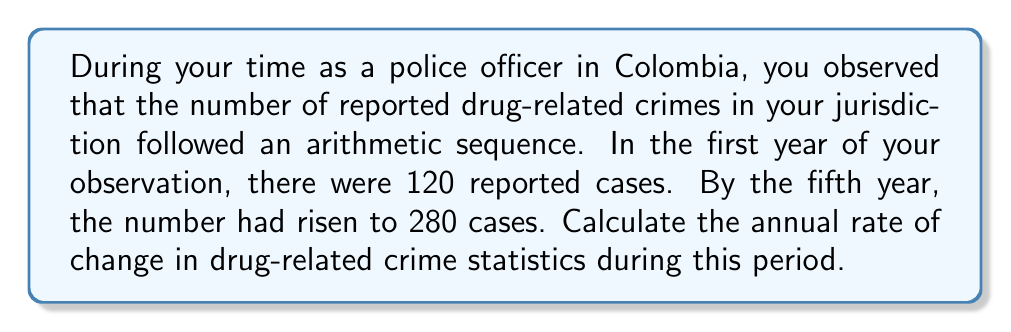Help me with this question. Let's approach this step-by-step:

1) We're dealing with an arithmetic sequence, where the difference between each term is constant. Let's call this common difference $d$.

2) We know two terms in this sequence:
   $a_1 = 120$ (first year)
   $a_5 = 280$ (fifth year)

3) In an arithmetic sequence, the nth term is given by:
   $a_n = a_1 + (n-1)d$

4) We can use this to set up an equation:
   $a_5 = a_1 + (5-1)d$
   $280 = 120 + 4d$

5) Solve for $d$:
   $280 - 120 = 4d$
   $160 = 4d$
   $d = 40$

6) The common difference $d$ represents the annual increase in reported cases, which is the rate of change we're looking for.

Therefore, the annual rate of change in drug-related crime statistics is 40 cases per year.
Answer: 40 cases per year 